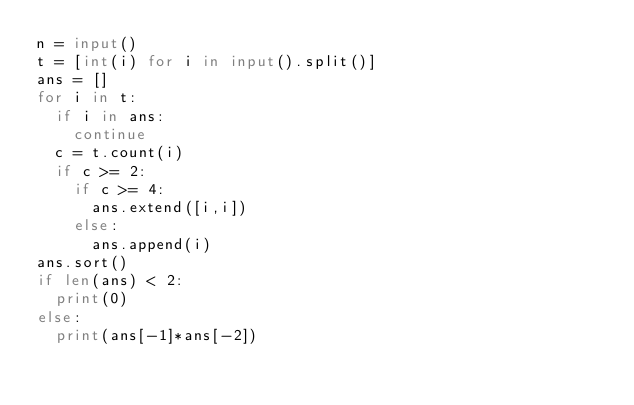<code> <loc_0><loc_0><loc_500><loc_500><_Python_>n = input()
t = [int(i) for i in input().split()]
ans = []
for i in t:
  if i in ans:
    continue
  c = t.count(i)
  if c >= 2:
    if c >= 4:
      ans.extend([i,i])
    else:
      ans.append(i)
ans.sort()
if len(ans) < 2:
  print(0)
else:
  print(ans[-1]*ans[-2])
</code> 